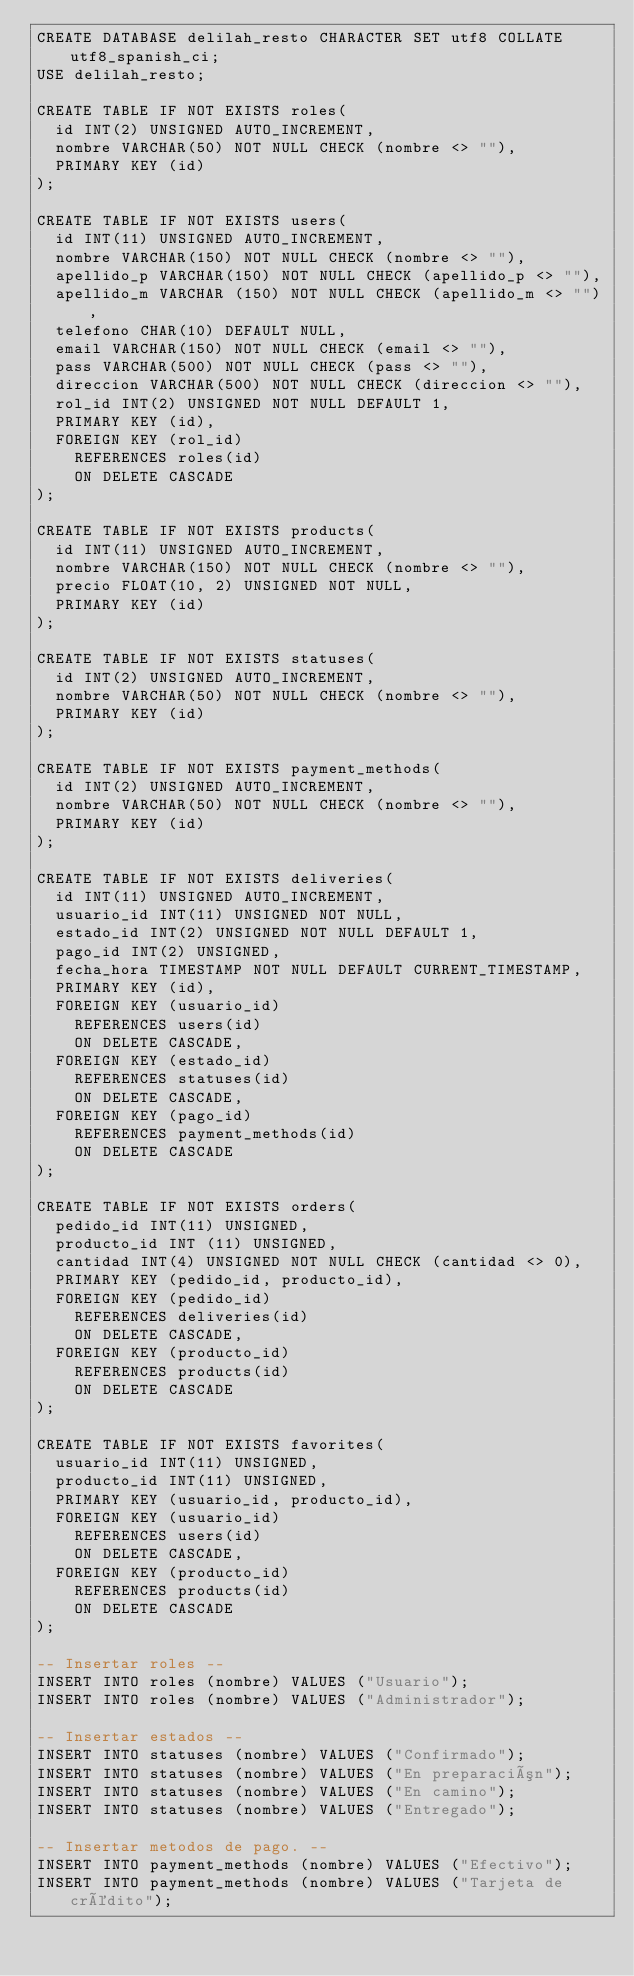<code> <loc_0><loc_0><loc_500><loc_500><_SQL_>CREATE DATABASE delilah_resto CHARACTER SET utf8 COLLATE utf8_spanish_ci;
USE delilah_resto;

CREATE TABLE IF NOT EXISTS roles(
	id INT(2) UNSIGNED AUTO_INCREMENT,
	nombre VARCHAR(50) NOT NULL CHECK (nombre <> ""),
	PRIMARY KEY (id)
);

CREATE TABLE IF NOT EXISTS users(
	id INT(11) UNSIGNED AUTO_INCREMENT,
	nombre VARCHAR(150) NOT NULL CHECK (nombre <> ""),
	apellido_p VARCHAR(150) NOT NULL CHECK (apellido_p <> ""),
	apellido_m VARCHAR (150) NOT NULL CHECK (apellido_m <> ""),
	telefono CHAR(10) DEFAULT NULL,
	email VARCHAR(150) NOT NULL CHECK (email <> ""),
	pass VARCHAR(500) NOT NULL CHECK (pass <> ""),
	direccion VARCHAR(500) NOT NULL CHECK (direccion <> ""),
	rol_id INT(2) UNSIGNED NOT NULL DEFAULT 1,
	PRIMARY KEY (id),
	FOREIGN KEY (rol_id)
		REFERENCES roles(id)
		ON DELETE CASCADE
);

CREATE TABLE IF NOT EXISTS products(
	id INT(11) UNSIGNED AUTO_INCREMENT,
	nombre VARCHAR(150) NOT NULL CHECK (nombre <> ""),
	precio FLOAT(10, 2) UNSIGNED NOT NULL,
	PRIMARY KEY (id)
);

CREATE TABLE IF NOT EXISTS statuses(
	id INT(2) UNSIGNED AUTO_INCREMENT,
	nombre VARCHAR(50) NOT NULL CHECK (nombre <> ""),
	PRIMARY KEY (id)
);

CREATE TABLE IF NOT EXISTS payment_methods(
	id INT(2) UNSIGNED AUTO_INCREMENT,
	nombre VARCHAR(50) NOT NULL CHECK (nombre <> ""),
	PRIMARY KEY (id)
);

CREATE TABLE IF NOT EXISTS deliveries(
	id INT(11) UNSIGNED AUTO_INCREMENT,
	usuario_id INT(11) UNSIGNED NOT NULL,
	estado_id INT(2) UNSIGNED NOT NULL DEFAULT 1,
	pago_id INT(2) UNSIGNED,
	fecha_hora TIMESTAMP NOT NULL DEFAULT CURRENT_TIMESTAMP,
	PRIMARY KEY (id),
	FOREIGN KEY (usuario_id)
		REFERENCES users(id)
		ON DELETE CASCADE,
	FOREIGN KEY (estado_id)
		REFERENCES statuses(id)
		ON DELETE CASCADE,
	FOREIGN KEY (pago_id)
		REFERENCES payment_methods(id)
		ON DELETE CASCADE
);

CREATE TABLE IF NOT EXISTS orders(
	pedido_id INT(11) UNSIGNED,
	producto_id INT (11) UNSIGNED,
	cantidad INT(4) UNSIGNED NOT NULL CHECK (cantidad <> 0),
	PRIMARY KEY (pedido_id, producto_id),
	FOREIGN KEY (pedido_id)
		REFERENCES deliveries(id)
		ON DELETE CASCADE,
	FOREIGN KEY (producto_id)
		REFERENCES products(id)
		ON DELETE CASCADE
);

CREATE TABLE IF NOT EXISTS favorites(
	usuario_id INT(11) UNSIGNED,
	producto_id INT(11) UNSIGNED,
	PRIMARY KEY (usuario_id, producto_id),
	FOREIGN KEY (usuario_id)
		REFERENCES users(id)
		ON DELETE CASCADE,
	FOREIGN KEY (producto_id)
		REFERENCES products(id)
		ON DELETE CASCADE
);

-- Insertar roles --
INSERT INTO roles (nombre) VALUES ("Usuario");
INSERT INTO roles (nombre) VALUES ("Administrador");

-- Insertar estados --
INSERT INTO statuses (nombre) VALUES ("Confirmado");
INSERT INTO statuses (nombre) VALUES ("En preparación");
INSERT INTO statuses (nombre) VALUES ("En camino");
INSERT INTO statuses (nombre) VALUES ("Entregado");

-- Insertar metodos de pago. --
INSERT INTO payment_methods (nombre) VALUES ("Efectivo");
INSERT INTO payment_methods (nombre) VALUES ("Tarjeta de crédito");</code> 